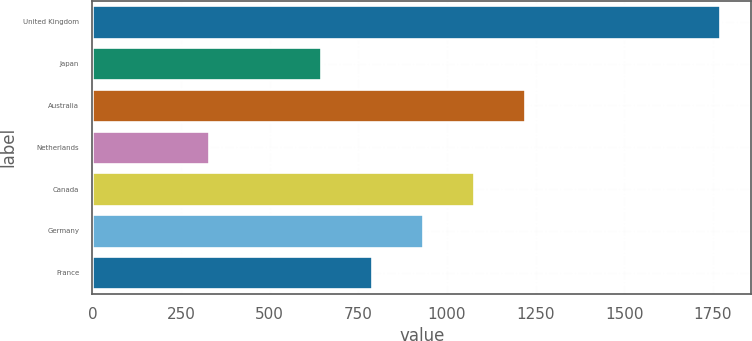Convert chart. <chart><loc_0><loc_0><loc_500><loc_500><bar_chart><fcel>United Kingdom<fcel>Japan<fcel>Australia<fcel>Netherlands<fcel>Canada<fcel>Germany<fcel>France<nl><fcel>1769<fcel>644<fcel>1219.6<fcel>330<fcel>1075.7<fcel>931.8<fcel>787.9<nl></chart> 